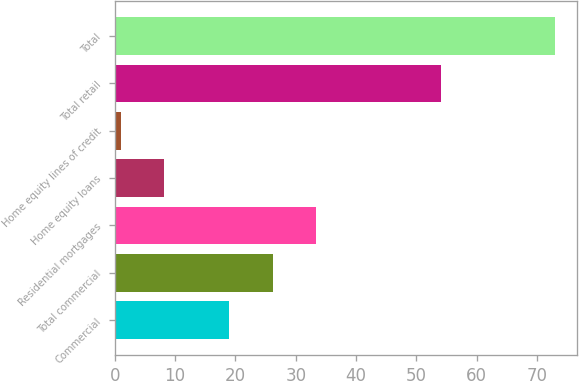<chart> <loc_0><loc_0><loc_500><loc_500><bar_chart><fcel>Commercial<fcel>Total commercial<fcel>Residential mortgages<fcel>Home equity loans<fcel>Home equity lines of credit<fcel>Total retail<fcel>Total<nl><fcel>19<fcel>26.2<fcel>33.4<fcel>8.2<fcel>1<fcel>54<fcel>73<nl></chart> 